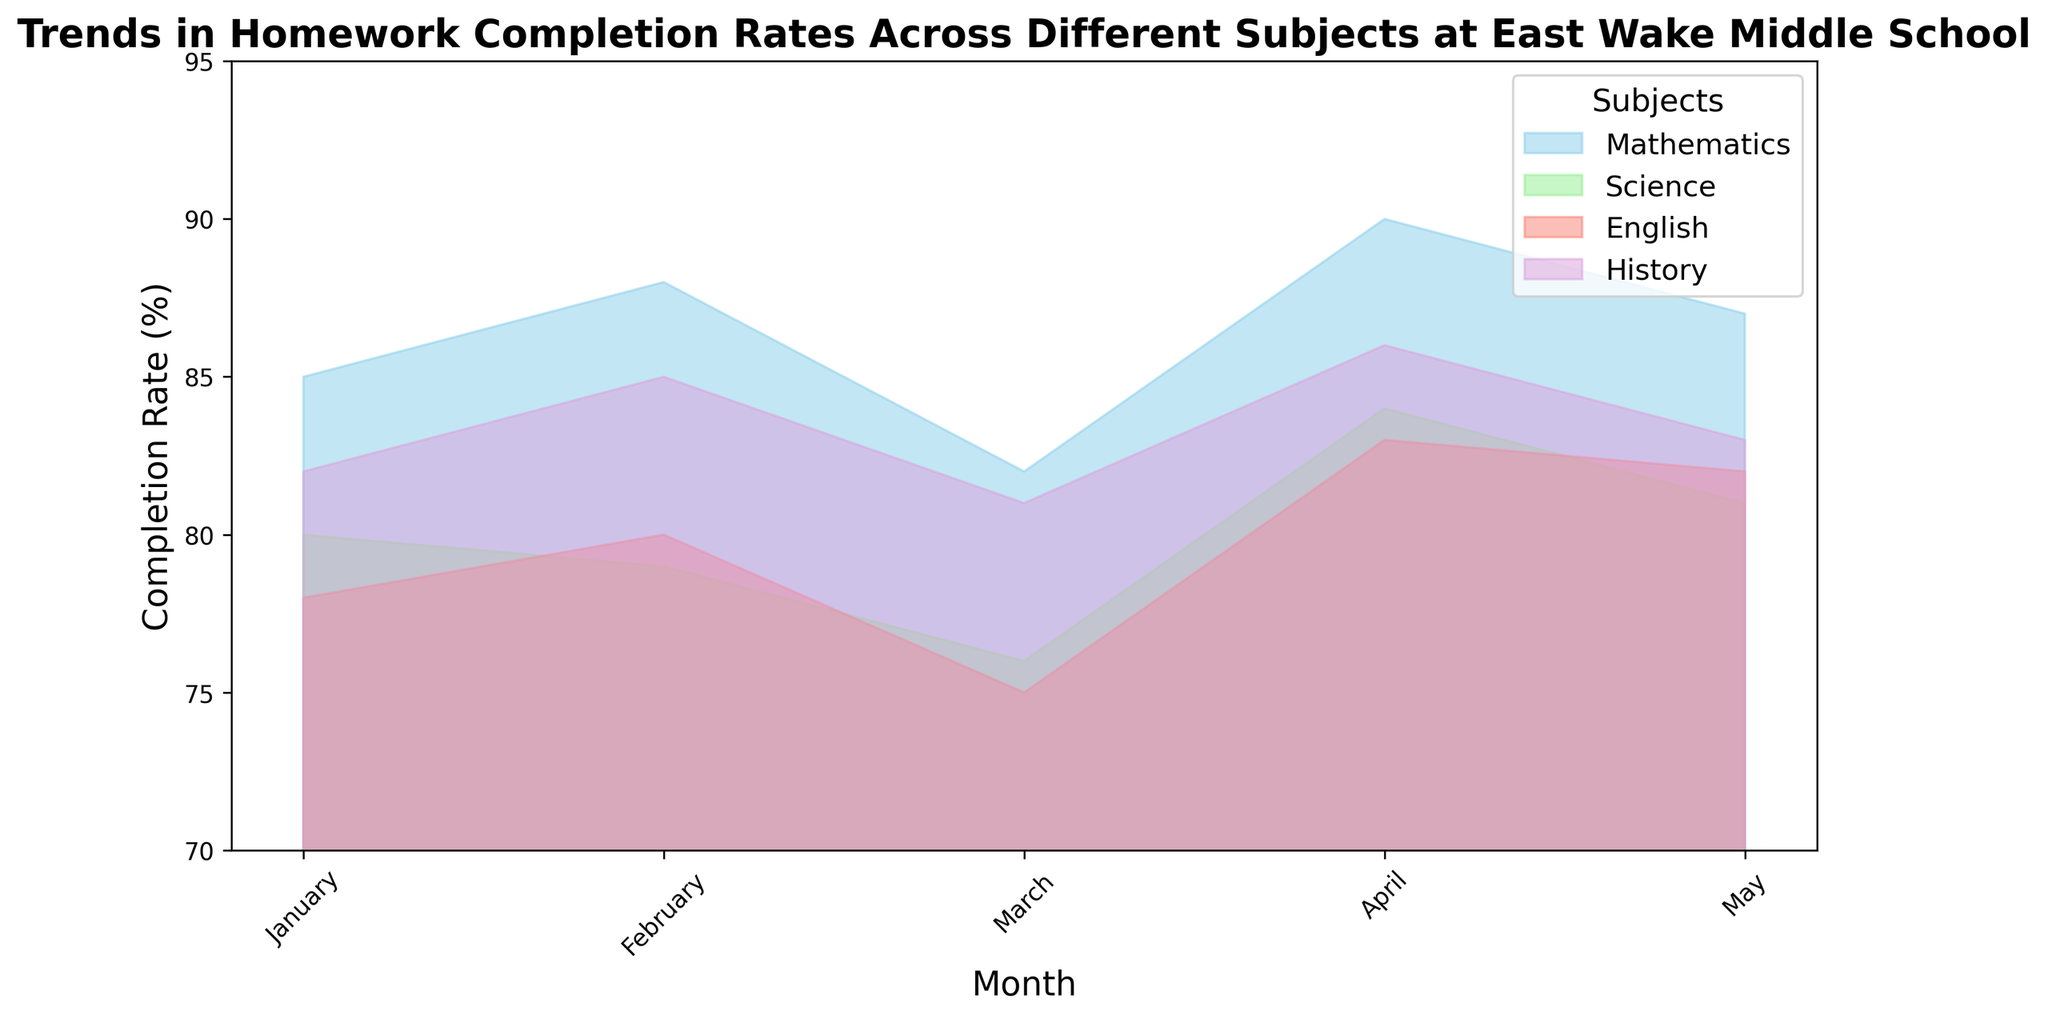Which subject had the highest homework completion rate in April? By looking at the figure, identify the highest peak among all subjects in April and check the corresponding subject. Mathematics reaches the peak at 90% in April.
Answer: Mathematics How did the completion rate for Science change from January to May? Examine the area representing Science and note the completion rates for January (80%) and May (81%). Subtract the January rate from the May rate: 81% - 80%. The rate increased by 1%.
Answer: Increased by 1% Among all subjects, which one showed the most significant improvement in homework completion rate from March to April? Check the completion rates for each subject in March and April. Calculate the differences: Mathematics (8%), Science (8%), English (8%), History (5%). The highest increase is in Mathematics, Science, and English.
Answer: Mathematics, Science, and English What is the average homework completion rate for English over the entire period? Sum all completion rates for English: 78 + 80 + 75 + 83 + 82 = 398. Divide by the number of months (5): 398 / 5. The average rate is 79.6%.
Answer: 79.6% Which subject had the most consistent homework completion rate over the months? Check the range (difference between highest and lowest values) for each subject. Mathematics (90-82=8), Science (84-76=8), English (83-75=8), History (86-81=5). History has the smallest range.
Answer: History In which month did Mathematics have its lowest completion rate, and what was it? Find the lowest point in the Mathematics area and check the corresponding month. In March, Mathematics had its lowest rate at 82%.
Answer: March, 82% Compare the completion rates for English and History in February. Which subject had a higher rate? Look at the heights of the English and History areas in February. English has 80%, History has 85%. History has a higher rate.
Answer: History What is the combined average completion rate for all subjects in May? Sum the May completion rates for each subject and divide by the number of subjects: (87 + 81 + 82 + 83) / 4. The combined average is 83.25%.
Answer: 83.25% How does the completion rate for Mathematics in February compare to the completion rate for Science in the same month? Check the rates for both subjects in February. Mathematics has 88%, and Science has 79%. Mathematics is higher.
Answer: Mathematics During which month did all subjects have above 80% completion rates? Examine the figure for months where all subjects have rates above 80%. In April, all subjects have rates above 80%.
Answer: April 